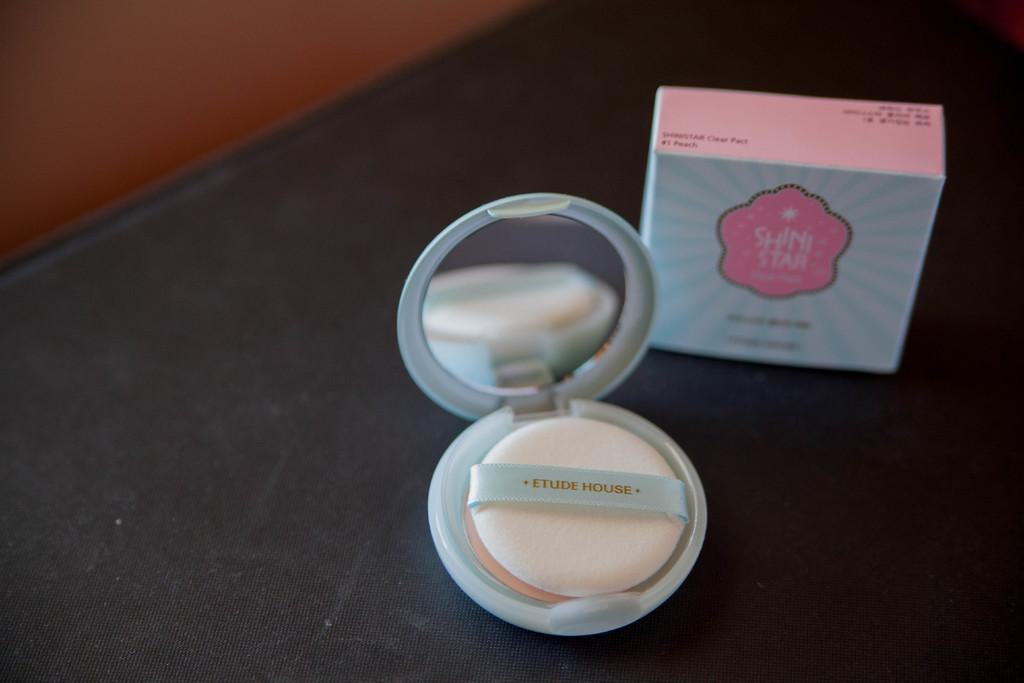<image>
Create a compact narrative representing the image presented. The makeup is labeled Etude House on the table. 